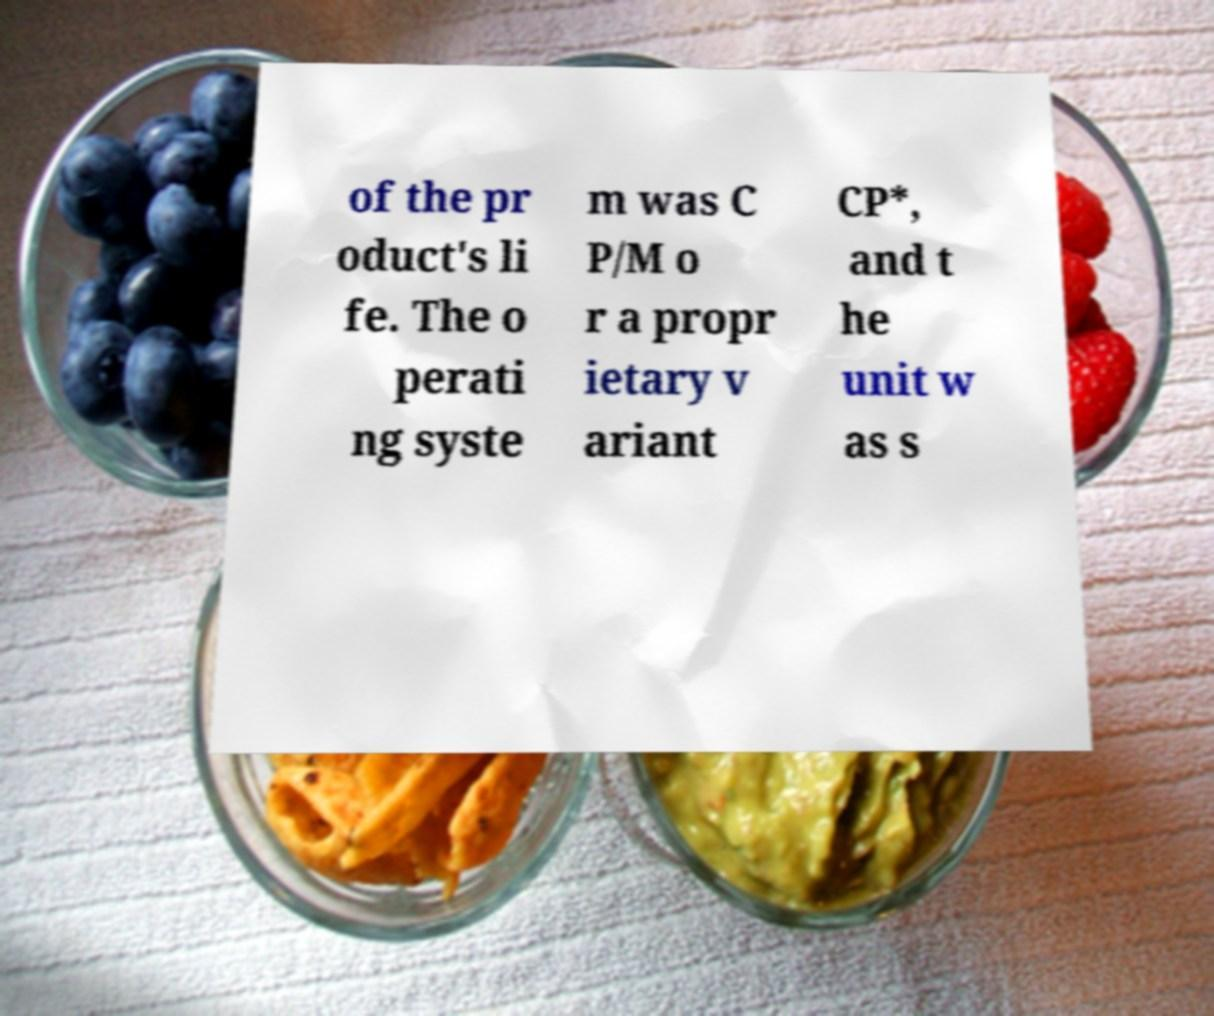Please read and relay the text visible in this image. What does it say? of the pr oduct's li fe. The o perati ng syste m was C P/M o r a propr ietary v ariant CP*, and t he unit w as s 